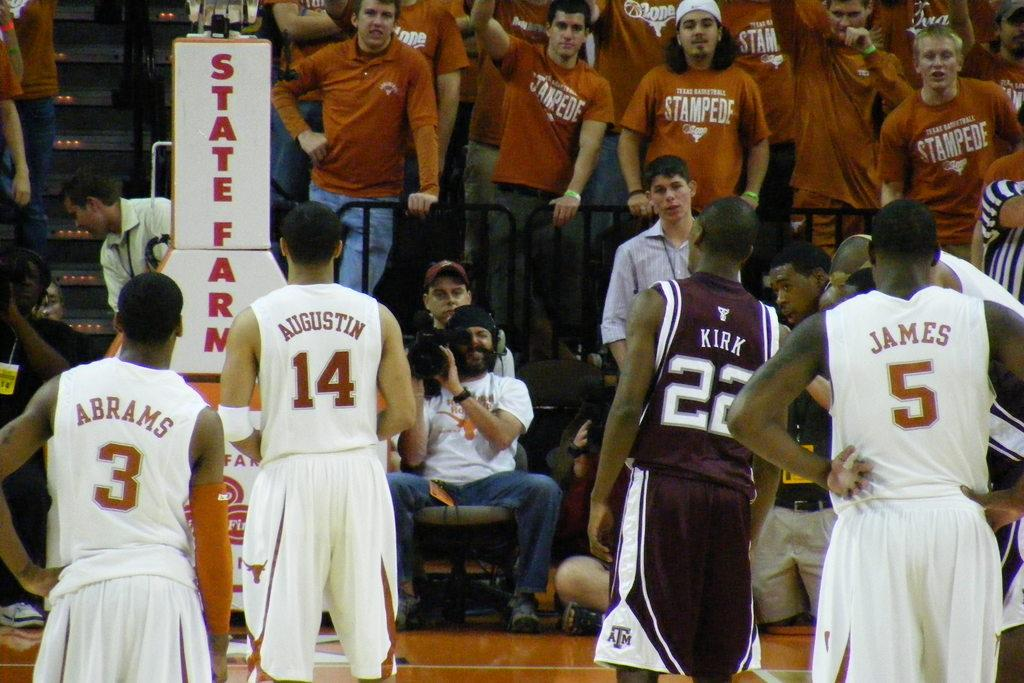<image>
Describe the image concisely. Several basketball players are looking towards the crowd with one having the number 5 on his shirt. 